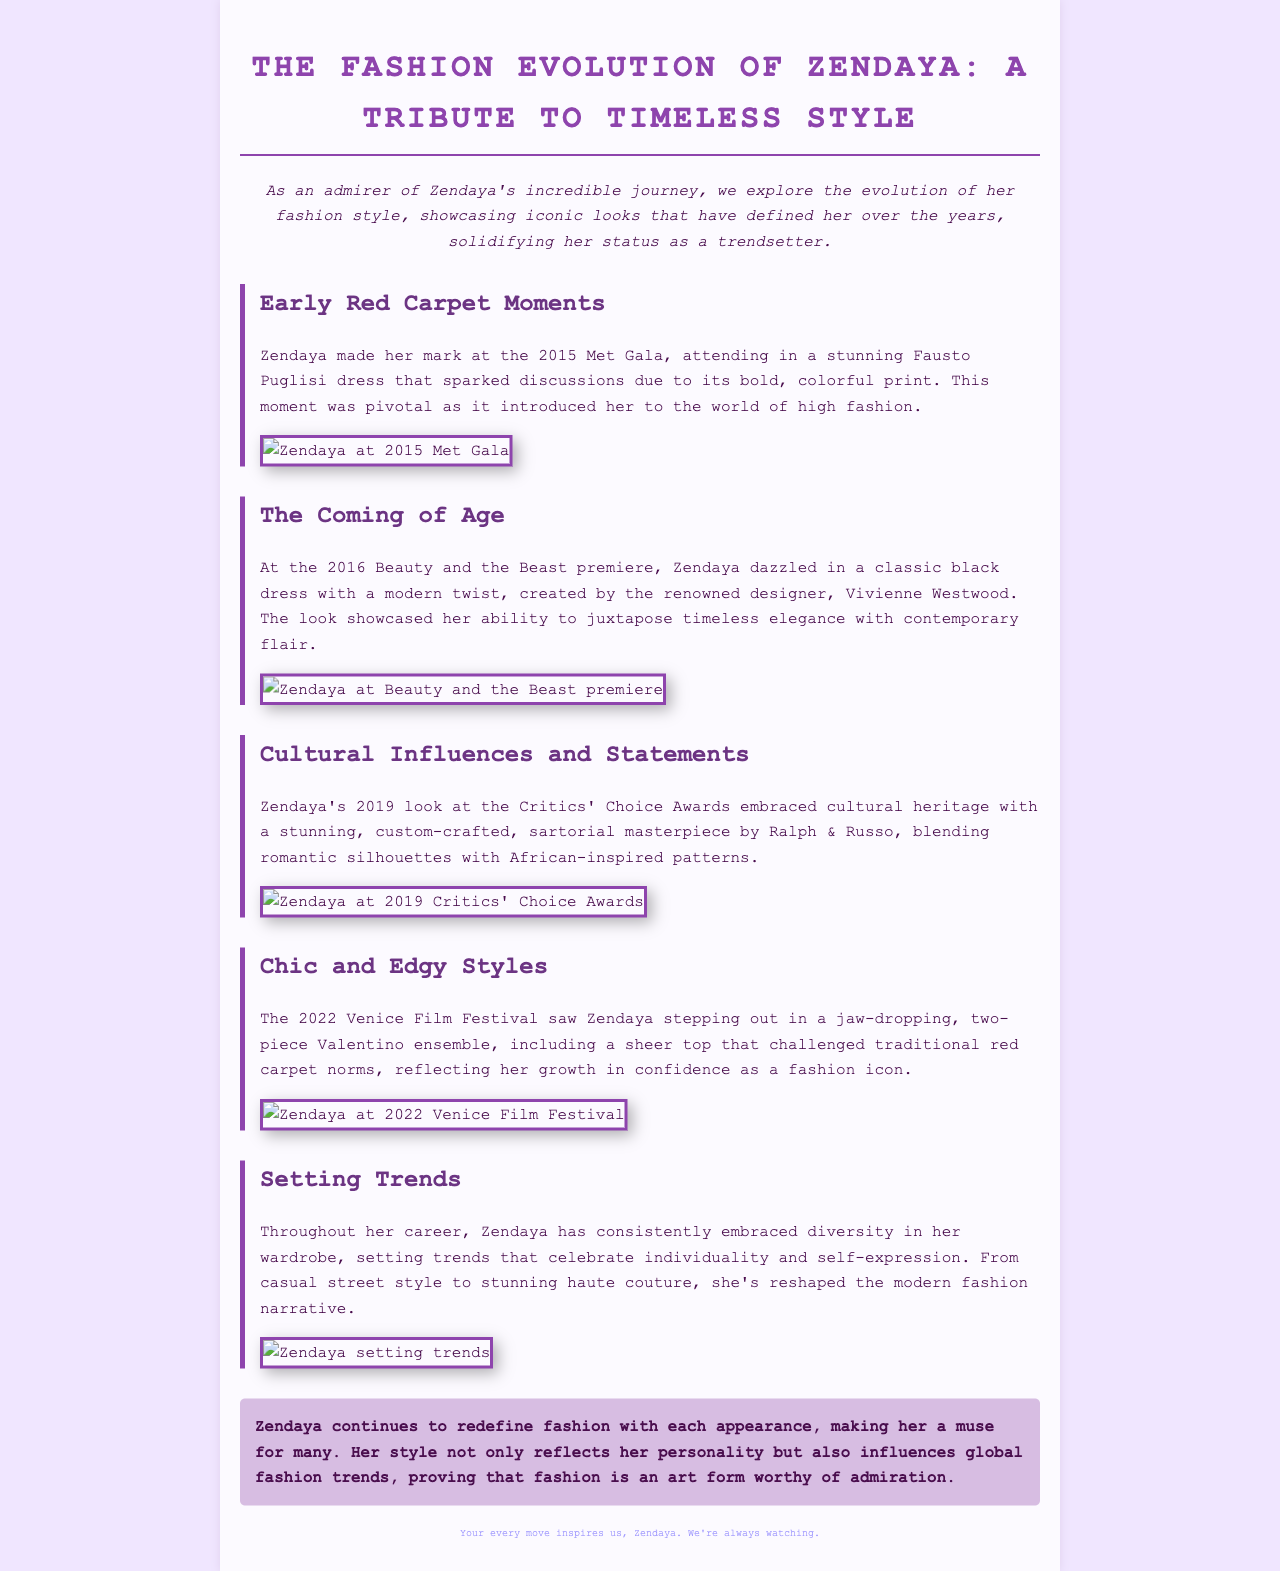what year did Zendaya make her mark at the Met Gala? Zendaya made her mark at the 2015 Met Gala, as stated in the document.
Answer: 2015 who designed the dress Zendaya wore at the Beauty and the Beast premiere? The dress Zendaya wore at the Beauty and the Beast premiere was created by Vivienne Westwood, as mentioned in the text.
Answer: Vivienne Westwood what cultural elements did Zendaya's dress at the Critics' Choice Awards reflect? The dress at the Critics' Choice Awards embraced cultural heritage with African-inspired patterns, highlighting the influence of her heritage.
Answer: African-inspired patterns how did Zendaya's style change at the Venice Film Festival in 2022? The 2022 Venice Film Festival look showcased her growth in confidence as a fashion icon by including a sheer top that challenged red carpet norms.
Answer: Growth in confidence what is a common theme in Zendaya's wardrobe choices according to the document? The document states that Zendaya consistently embraces diversity in her wardrobe, setting trends that celebrate individuality and self-expression.
Answer: Diversity how many notable sections are detailed in the document about Zendaya's fashion evolution? The document includes five sections detailing various aspects of Zendaya's fashion evolution.
Answer: Five what is the primary purpose of this newsletter? The newsletter aims to explore the evolution of Zendaya's fashion style and her status as a trendsetter, as stated in the introduction.
Answer: Explore Zendaya's fashion style what color is the background of the document? The background color of the document is #f0e6ff, a light hue, as described in the code.
Answer: Light purple what approach does the newsletter take regarding Zendaya's impact on fashion trends? The newsletter conveys that Zendaya influences global fashion trends and reshapes the modern fashion narrative through her style.
Answer: Influences global fashion trends 